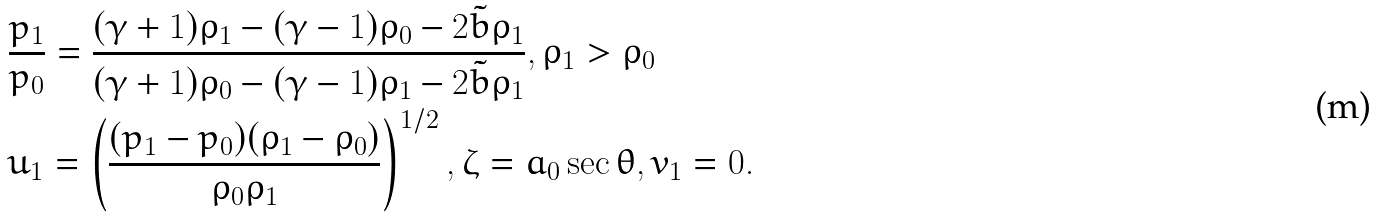<formula> <loc_0><loc_0><loc_500><loc_500>& \frac { p _ { 1 } } { p _ { 0 } } = \frac { ( \gamma + 1 ) \rho _ { 1 } - ( \gamma - 1 ) \rho _ { 0 } - 2 \tilde { b } { \rho _ { 1 } } } { ( \gamma + 1 ) \rho _ { 0 } - ( \gamma - 1 ) \rho _ { 1 } - 2 \tilde { b } { \rho _ { 1 } } } , \rho _ { 1 } > \rho _ { 0 } \\ & u _ { 1 } = \left ( \frac { ( p _ { 1 } - p _ { 0 } ) ( \rho _ { 1 } - \rho _ { 0 } ) } { { \rho _ { 0 } } { \rho } _ { 1 } } \right ) ^ { 1 / 2 } , \zeta = a _ { 0 } \sec { \theta } , v _ { 1 } = 0 .</formula> 